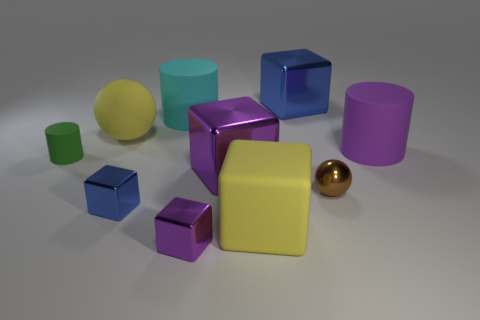Is the number of large blue objects less than the number of large rubber cylinders?
Make the answer very short. Yes. Does the large blue thing have the same material as the big yellow ball?
Provide a short and direct response. No. How many other objects are the same color as the matte sphere?
Your answer should be very brief. 1. Is the number of red matte balls greater than the number of big purple things?
Make the answer very short. No. There is a purple rubber thing; is it the same size as the blue block that is in front of the brown ball?
Your answer should be compact. No. What is the color of the small metallic cube that is on the right side of the large cyan matte thing?
Give a very brief answer. Purple. How many cyan objects are large things or cylinders?
Give a very brief answer. 1. What is the color of the big rubber ball?
Provide a short and direct response. Yellow. Is there any other thing that is the same material as the small purple block?
Offer a very short reply. Yes. Are there fewer matte objects that are behind the tiny blue cube than purple shiny things that are right of the big blue shiny block?
Provide a succinct answer. No. 